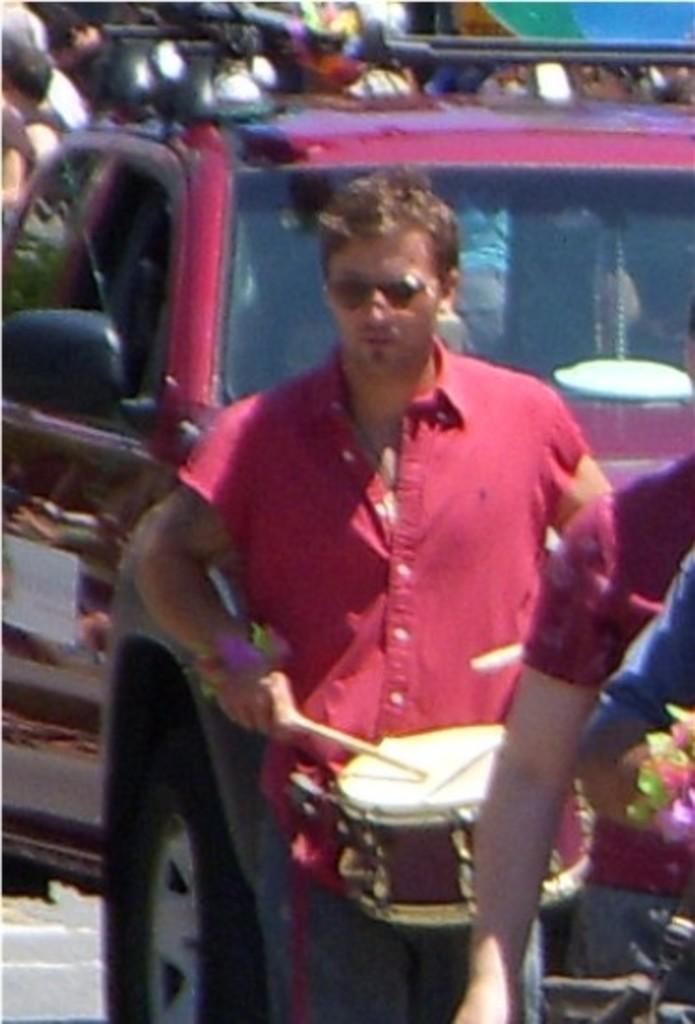How would you summarize this image in a sentence or two? In this image we can see a person playing a musical instrument, behind him we can see a vehicle and in the background there are some people. 